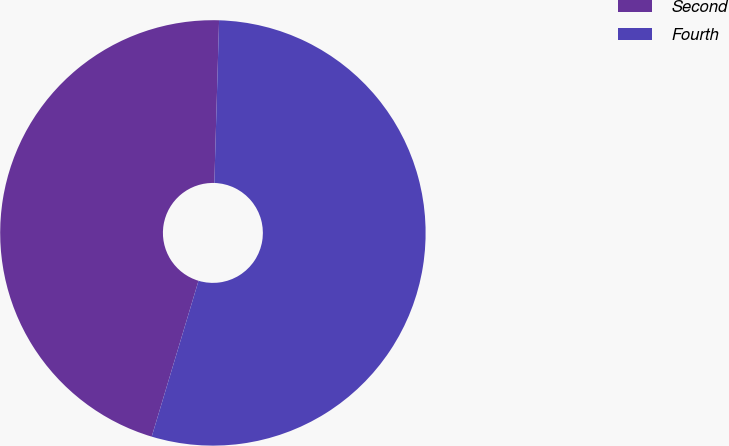<chart> <loc_0><loc_0><loc_500><loc_500><pie_chart><fcel>Second<fcel>Fourth<nl><fcel>45.82%<fcel>54.18%<nl></chart> 